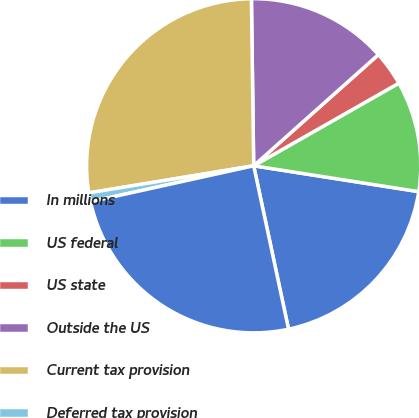Convert chart to OTSL. <chart><loc_0><loc_0><loc_500><loc_500><pie_chart><fcel>In millions<fcel>US federal<fcel>US state<fcel>Outside the US<fcel>Current tax provision<fcel>Deferred tax provision<fcel>Provision for income taxes<nl><fcel>19.18%<fcel>10.71%<fcel>3.35%<fcel>13.63%<fcel>27.38%<fcel>0.86%<fcel>24.89%<nl></chart> 